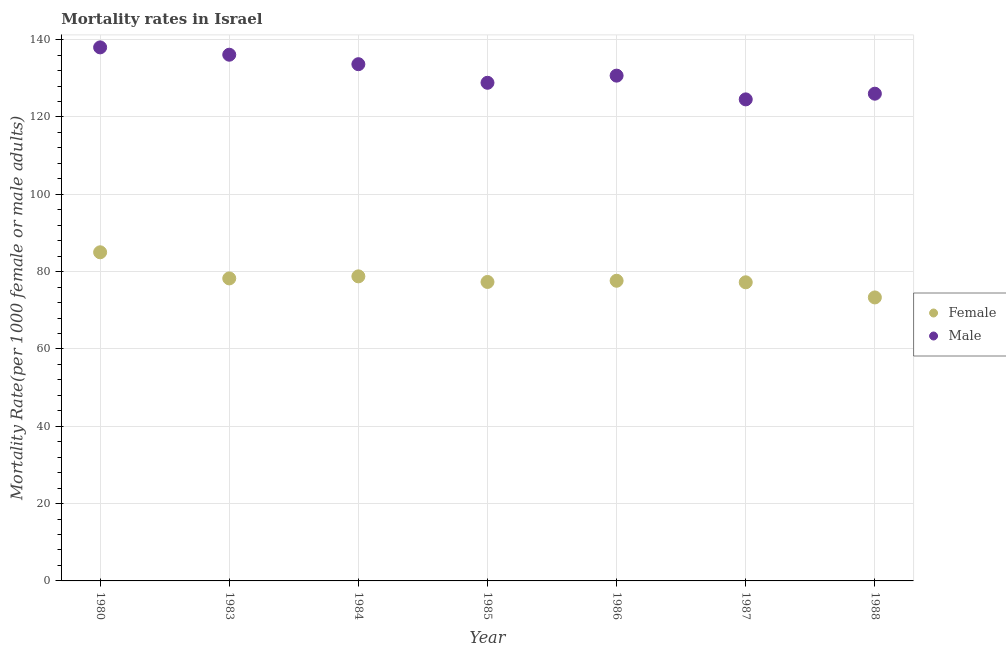How many different coloured dotlines are there?
Offer a terse response. 2. What is the female mortality rate in 1987?
Offer a terse response. 77.24. Across all years, what is the minimum female mortality rate?
Provide a short and direct response. 73.32. What is the total male mortality rate in the graph?
Offer a terse response. 917.86. What is the difference between the male mortality rate in 1987 and that in 1988?
Your answer should be compact. -1.47. What is the difference between the female mortality rate in 1985 and the male mortality rate in 1983?
Your answer should be compact. -58.78. What is the average female mortality rate per year?
Your answer should be very brief. 78.22. In the year 1980, what is the difference between the female mortality rate and male mortality rate?
Your answer should be very brief. -53. What is the ratio of the male mortality rate in 1985 to that in 1986?
Your answer should be compact. 0.99. Is the male mortality rate in 1983 less than that in 1986?
Your response must be concise. No. Is the difference between the female mortality rate in 1980 and 1985 greater than the difference between the male mortality rate in 1980 and 1985?
Your answer should be compact. No. What is the difference between the highest and the second highest female mortality rate?
Provide a short and direct response. 6.22. What is the difference between the highest and the lowest female mortality rate?
Your answer should be very brief. 11.68. Where does the legend appear in the graph?
Provide a succinct answer. Center right. How many legend labels are there?
Give a very brief answer. 2. How are the legend labels stacked?
Offer a very short reply. Vertical. What is the title of the graph?
Make the answer very short. Mortality rates in Israel. What is the label or title of the Y-axis?
Give a very brief answer. Mortality Rate(per 1000 female or male adults). What is the Mortality Rate(per 1000 female or male adults) of Male in 1980?
Make the answer very short. 138. What is the Mortality Rate(per 1000 female or male adults) of Female in 1983?
Provide a short and direct response. 78.24. What is the Mortality Rate(per 1000 female or male adults) in Male in 1983?
Your response must be concise. 136.1. What is the Mortality Rate(per 1000 female or male adults) of Female in 1984?
Your answer should be compact. 78.78. What is the Mortality Rate(per 1000 female or male adults) of Male in 1984?
Make the answer very short. 133.65. What is the Mortality Rate(per 1000 female or male adults) in Female in 1985?
Offer a very short reply. 77.33. What is the Mortality Rate(per 1000 female or male adults) of Male in 1985?
Ensure brevity in your answer.  128.84. What is the Mortality Rate(per 1000 female or male adults) of Female in 1986?
Your response must be concise. 77.64. What is the Mortality Rate(per 1000 female or male adults) in Male in 1986?
Offer a terse response. 130.69. What is the Mortality Rate(per 1000 female or male adults) of Female in 1987?
Offer a terse response. 77.24. What is the Mortality Rate(per 1000 female or male adults) in Male in 1987?
Provide a succinct answer. 124.55. What is the Mortality Rate(per 1000 female or male adults) of Female in 1988?
Offer a very short reply. 73.32. What is the Mortality Rate(per 1000 female or male adults) of Male in 1988?
Provide a short and direct response. 126.02. Across all years, what is the maximum Mortality Rate(per 1000 female or male adults) in Male?
Make the answer very short. 138. Across all years, what is the minimum Mortality Rate(per 1000 female or male adults) of Female?
Provide a short and direct response. 73.32. Across all years, what is the minimum Mortality Rate(per 1000 female or male adults) in Male?
Offer a very short reply. 124.55. What is the total Mortality Rate(per 1000 female or male adults) of Female in the graph?
Ensure brevity in your answer.  547.54. What is the total Mortality Rate(per 1000 female or male adults) of Male in the graph?
Your response must be concise. 917.86. What is the difference between the Mortality Rate(per 1000 female or male adults) of Female in 1980 and that in 1983?
Provide a short and direct response. 6.76. What is the difference between the Mortality Rate(per 1000 female or male adults) of Male in 1980 and that in 1983?
Your answer should be very brief. 1.9. What is the difference between the Mortality Rate(per 1000 female or male adults) in Female in 1980 and that in 1984?
Make the answer very short. 6.22. What is the difference between the Mortality Rate(per 1000 female or male adults) of Male in 1980 and that in 1984?
Your answer should be very brief. 4.35. What is the difference between the Mortality Rate(per 1000 female or male adults) in Female in 1980 and that in 1985?
Offer a very short reply. 7.67. What is the difference between the Mortality Rate(per 1000 female or male adults) of Male in 1980 and that in 1985?
Offer a terse response. 9.16. What is the difference between the Mortality Rate(per 1000 female or male adults) of Female in 1980 and that in 1986?
Offer a very short reply. 7.36. What is the difference between the Mortality Rate(per 1000 female or male adults) of Male in 1980 and that in 1986?
Your answer should be compact. 7.31. What is the difference between the Mortality Rate(per 1000 female or male adults) of Female in 1980 and that in 1987?
Offer a terse response. 7.76. What is the difference between the Mortality Rate(per 1000 female or male adults) in Male in 1980 and that in 1987?
Provide a succinct answer. 13.45. What is the difference between the Mortality Rate(per 1000 female or male adults) in Female in 1980 and that in 1988?
Your answer should be compact. 11.68. What is the difference between the Mortality Rate(per 1000 female or male adults) in Male in 1980 and that in 1988?
Offer a very short reply. 11.98. What is the difference between the Mortality Rate(per 1000 female or male adults) in Female in 1983 and that in 1984?
Keep it short and to the point. -0.53. What is the difference between the Mortality Rate(per 1000 female or male adults) of Male in 1983 and that in 1984?
Offer a very short reply. 2.45. What is the difference between the Mortality Rate(per 1000 female or male adults) of Female in 1983 and that in 1985?
Make the answer very short. 0.92. What is the difference between the Mortality Rate(per 1000 female or male adults) of Male in 1983 and that in 1985?
Make the answer very short. 7.26. What is the difference between the Mortality Rate(per 1000 female or male adults) in Female in 1983 and that in 1986?
Offer a terse response. 0.61. What is the difference between the Mortality Rate(per 1000 female or male adults) of Male in 1983 and that in 1986?
Make the answer very short. 5.41. What is the difference between the Mortality Rate(per 1000 female or male adults) of Male in 1983 and that in 1987?
Provide a short and direct response. 11.55. What is the difference between the Mortality Rate(per 1000 female or male adults) of Female in 1983 and that in 1988?
Give a very brief answer. 4.92. What is the difference between the Mortality Rate(per 1000 female or male adults) in Male in 1983 and that in 1988?
Keep it short and to the point. 10.08. What is the difference between the Mortality Rate(per 1000 female or male adults) of Female in 1984 and that in 1985?
Give a very brief answer. 1.45. What is the difference between the Mortality Rate(per 1000 female or male adults) in Male in 1984 and that in 1985?
Keep it short and to the point. 4.81. What is the difference between the Mortality Rate(per 1000 female or male adults) in Female in 1984 and that in 1986?
Offer a terse response. 1.14. What is the difference between the Mortality Rate(per 1000 female or male adults) of Male in 1984 and that in 1986?
Give a very brief answer. 2.96. What is the difference between the Mortality Rate(per 1000 female or male adults) in Female in 1984 and that in 1987?
Make the answer very short. 1.54. What is the difference between the Mortality Rate(per 1000 female or male adults) in Male in 1984 and that in 1987?
Provide a short and direct response. 9.1. What is the difference between the Mortality Rate(per 1000 female or male adults) of Female in 1984 and that in 1988?
Your answer should be very brief. 5.45. What is the difference between the Mortality Rate(per 1000 female or male adults) of Male in 1984 and that in 1988?
Give a very brief answer. 7.63. What is the difference between the Mortality Rate(per 1000 female or male adults) in Female in 1985 and that in 1986?
Make the answer very short. -0.31. What is the difference between the Mortality Rate(per 1000 female or male adults) in Male in 1985 and that in 1986?
Your answer should be compact. -1.85. What is the difference between the Mortality Rate(per 1000 female or male adults) in Female in 1985 and that in 1987?
Your answer should be very brief. 0.09. What is the difference between the Mortality Rate(per 1000 female or male adults) of Male in 1985 and that in 1987?
Make the answer very short. 4.29. What is the difference between the Mortality Rate(per 1000 female or male adults) in Female in 1985 and that in 1988?
Make the answer very short. 4. What is the difference between the Mortality Rate(per 1000 female or male adults) of Male in 1985 and that in 1988?
Offer a terse response. 2.82. What is the difference between the Mortality Rate(per 1000 female or male adults) of Female in 1986 and that in 1987?
Offer a terse response. 0.4. What is the difference between the Mortality Rate(per 1000 female or male adults) in Male in 1986 and that in 1987?
Your response must be concise. 6.14. What is the difference between the Mortality Rate(per 1000 female or male adults) in Female in 1986 and that in 1988?
Ensure brevity in your answer.  4.31. What is the difference between the Mortality Rate(per 1000 female or male adults) in Male in 1986 and that in 1988?
Offer a terse response. 4.67. What is the difference between the Mortality Rate(per 1000 female or male adults) in Female in 1987 and that in 1988?
Ensure brevity in your answer.  3.92. What is the difference between the Mortality Rate(per 1000 female or male adults) in Male in 1987 and that in 1988?
Offer a very short reply. -1.47. What is the difference between the Mortality Rate(per 1000 female or male adults) of Female in 1980 and the Mortality Rate(per 1000 female or male adults) of Male in 1983?
Make the answer very short. -51.1. What is the difference between the Mortality Rate(per 1000 female or male adults) in Female in 1980 and the Mortality Rate(per 1000 female or male adults) in Male in 1984?
Offer a terse response. -48.65. What is the difference between the Mortality Rate(per 1000 female or male adults) in Female in 1980 and the Mortality Rate(per 1000 female or male adults) in Male in 1985?
Give a very brief answer. -43.84. What is the difference between the Mortality Rate(per 1000 female or male adults) of Female in 1980 and the Mortality Rate(per 1000 female or male adults) of Male in 1986?
Provide a short and direct response. -45.69. What is the difference between the Mortality Rate(per 1000 female or male adults) in Female in 1980 and the Mortality Rate(per 1000 female or male adults) in Male in 1987?
Make the answer very short. -39.55. What is the difference between the Mortality Rate(per 1000 female or male adults) in Female in 1980 and the Mortality Rate(per 1000 female or male adults) in Male in 1988?
Your answer should be very brief. -41.02. What is the difference between the Mortality Rate(per 1000 female or male adults) in Female in 1983 and the Mortality Rate(per 1000 female or male adults) in Male in 1984?
Keep it short and to the point. -55.41. What is the difference between the Mortality Rate(per 1000 female or male adults) of Female in 1983 and the Mortality Rate(per 1000 female or male adults) of Male in 1985?
Your answer should be compact. -50.6. What is the difference between the Mortality Rate(per 1000 female or male adults) of Female in 1983 and the Mortality Rate(per 1000 female or male adults) of Male in 1986?
Give a very brief answer. -52.45. What is the difference between the Mortality Rate(per 1000 female or male adults) in Female in 1983 and the Mortality Rate(per 1000 female or male adults) in Male in 1987?
Make the answer very short. -46.31. What is the difference between the Mortality Rate(per 1000 female or male adults) in Female in 1983 and the Mortality Rate(per 1000 female or male adults) in Male in 1988?
Offer a terse response. -47.78. What is the difference between the Mortality Rate(per 1000 female or male adults) in Female in 1984 and the Mortality Rate(per 1000 female or male adults) in Male in 1985?
Provide a succinct answer. -50.07. What is the difference between the Mortality Rate(per 1000 female or male adults) in Female in 1984 and the Mortality Rate(per 1000 female or male adults) in Male in 1986?
Ensure brevity in your answer.  -51.91. What is the difference between the Mortality Rate(per 1000 female or male adults) of Female in 1984 and the Mortality Rate(per 1000 female or male adults) of Male in 1987?
Offer a terse response. -45.77. What is the difference between the Mortality Rate(per 1000 female or male adults) of Female in 1984 and the Mortality Rate(per 1000 female or male adults) of Male in 1988?
Your answer should be compact. -47.25. What is the difference between the Mortality Rate(per 1000 female or male adults) of Female in 1985 and the Mortality Rate(per 1000 female or male adults) of Male in 1986?
Offer a very short reply. -53.37. What is the difference between the Mortality Rate(per 1000 female or male adults) of Female in 1985 and the Mortality Rate(per 1000 female or male adults) of Male in 1987?
Your answer should be very brief. -47.23. What is the difference between the Mortality Rate(per 1000 female or male adults) of Female in 1985 and the Mortality Rate(per 1000 female or male adults) of Male in 1988?
Offer a very short reply. -48.7. What is the difference between the Mortality Rate(per 1000 female or male adults) of Female in 1986 and the Mortality Rate(per 1000 female or male adults) of Male in 1987?
Keep it short and to the point. -46.91. What is the difference between the Mortality Rate(per 1000 female or male adults) in Female in 1986 and the Mortality Rate(per 1000 female or male adults) in Male in 1988?
Offer a terse response. -48.39. What is the difference between the Mortality Rate(per 1000 female or male adults) of Female in 1987 and the Mortality Rate(per 1000 female or male adults) of Male in 1988?
Offer a terse response. -48.78. What is the average Mortality Rate(per 1000 female or male adults) in Female per year?
Your answer should be very brief. 78.22. What is the average Mortality Rate(per 1000 female or male adults) of Male per year?
Offer a very short reply. 131.12. In the year 1980, what is the difference between the Mortality Rate(per 1000 female or male adults) in Female and Mortality Rate(per 1000 female or male adults) in Male?
Provide a short and direct response. -53. In the year 1983, what is the difference between the Mortality Rate(per 1000 female or male adults) of Female and Mortality Rate(per 1000 female or male adults) of Male?
Offer a very short reply. -57.86. In the year 1984, what is the difference between the Mortality Rate(per 1000 female or male adults) in Female and Mortality Rate(per 1000 female or male adults) in Male?
Your answer should be compact. -54.88. In the year 1985, what is the difference between the Mortality Rate(per 1000 female or male adults) in Female and Mortality Rate(per 1000 female or male adults) in Male?
Provide a short and direct response. -51.52. In the year 1986, what is the difference between the Mortality Rate(per 1000 female or male adults) of Female and Mortality Rate(per 1000 female or male adults) of Male?
Offer a very short reply. -53.05. In the year 1987, what is the difference between the Mortality Rate(per 1000 female or male adults) of Female and Mortality Rate(per 1000 female or male adults) of Male?
Make the answer very short. -47.31. In the year 1988, what is the difference between the Mortality Rate(per 1000 female or male adults) of Female and Mortality Rate(per 1000 female or male adults) of Male?
Make the answer very short. -52.7. What is the ratio of the Mortality Rate(per 1000 female or male adults) in Female in 1980 to that in 1983?
Give a very brief answer. 1.09. What is the ratio of the Mortality Rate(per 1000 female or male adults) in Male in 1980 to that in 1983?
Offer a very short reply. 1.01. What is the ratio of the Mortality Rate(per 1000 female or male adults) of Female in 1980 to that in 1984?
Ensure brevity in your answer.  1.08. What is the ratio of the Mortality Rate(per 1000 female or male adults) of Male in 1980 to that in 1984?
Your answer should be very brief. 1.03. What is the ratio of the Mortality Rate(per 1000 female or male adults) in Female in 1980 to that in 1985?
Your response must be concise. 1.1. What is the ratio of the Mortality Rate(per 1000 female or male adults) of Male in 1980 to that in 1985?
Ensure brevity in your answer.  1.07. What is the ratio of the Mortality Rate(per 1000 female or male adults) in Female in 1980 to that in 1986?
Give a very brief answer. 1.09. What is the ratio of the Mortality Rate(per 1000 female or male adults) of Male in 1980 to that in 1986?
Provide a succinct answer. 1.06. What is the ratio of the Mortality Rate(per 1000 female or male adults) of Female in 1980 to that in 1987?
Provide a succinct answer. 1.1. What is the ratio of the Mortality Rate(per 1000 female or male adults) in Male in 1980 to that in 1987?
Your answer should be very brief. 1.11. What is the ratio of the Mortality Rate(per 1000 female or male adults) in Female in 1980 to that in 1988?
Offer a terse response. 1.16. What is the ratio of the Mortality Rate(per 1000 female or male adults) of Male in 1980 to that in 1988?
Offer a terse response. 1.09. What is the ratio of the Mortality Rate(per 1000 female or male adults) of Female in 1983 to that in 1984?
Ensure brevity in your answer.  0.99. What is the ratio of the Mortality Rate(per 1000 female or male adults) of Male in 1983 to that in 1984?
Provide a succinct answer. 1.02. What is the ratio of the Mortality Rate(per 1000 female or male adults) of Female in 1983 to that in 1985?
Your answer should be very brief. 1.01. What is the ratio of the Mortality Rate(per 1000 female or male adults) in Male in 1983 to that in 1985?
Your answer should be compact. 1.06. What is the ratio of the Mortality Rate(per 1000 female or male adults) in Male in 1983 to that in 1986?
Your answer should be very brief. 1.04. What is the ratio of the Mortality Rate(per 1000 female or male adults) of Female in 1983 to that in 1987?
Ensure brevity in your answer.  1.01. What is the ratio of the Mortality Rate(per 1000 female or male adults) of Male in 1983 to that in 1987?
Offer a terse response. 1.09. What is the ratio of the Mortality Rate(per 1000 female or male adults) of Female in 1983 to that in 1988?
Provide a short and direct response. 1.07. What is the ratio of the Mortality Rate(per 1000 female or male adults) of Male in 1983 to that in 1988?
Give a very brief answer. 1.08. What is the ratio of the Mortality Rate(per 1000 female or male adults) in Female in 1984 to that in 1985?
Make the answer very short. 1.02. What is the ratio of the Mortality Rate(per 1000 female or male adults) in Male in 1984 to that in 1985?
Give a very brief answer. 1.04. What is the ratio of the Mortality Rate(per 1000 female or male adults) of Female in 1984 to that in 1986?
Ensure brevity in your answer.  1.01. What is the ratio of the Mortality Rate(per 1000 female or male adults) of Male in 1984 to that in 1986?
Your answer should be compact. 1.02. What is the ratio of the Mortality Rate(per 1000 female or male adults) in Female in 1984 to that in 1987?
Make the answer very short. 1.02. What is the ratio of the Mortality Rate(per 1000 female or male adults) in Male in 1984 to that in 1987?
Your answer should be very brief. 1.07. What is the ratio of the Mortality Rate(per 1000 female or male adults) in Female in 1984 to that in 1988?
Make the answer very short. 1.07. What is the ratio of the Mortality Rate(per 1000 female or male adults) in Male in 1984 to that in 1988?
Your answer should be very brief. 1.06. What is the ratio of the Mortality Rate(per 1000 female or male adults) in Male in 1985 to that in 1986?
Make the answer very short. 0.99. What is the ratio of the Mortality Rate(per 1000 female or male adults) in Male in 1985 to that in 1987?
Your answer should be very brief. 1.03. What is the ratio of the Mortality Rate(per 1000 female or male adults) of Female in 1985 to that in 1988?
Provide a succinct answer. 1.05. What is the ratio of the Mortality Rate(per 1000 female or male adults) of Male in 1985 to that in 1988?
Offer a very short reply. 1.02. What is the ratio of the Mortality Rate(per 1000 female or male adults) of Female in 1986 to that in 1987?
Ensure brevity in your answer.  1.01. What is the ratio of the Mortality Rate(per 1000 female or male adults) in Male in 1986 to that in 1987?
Provide a succinct answer. 1.05. What is the ratio of the Mortality Rate(per 1000 female or male adults) in Female in 1986 to that in 1988?
Give a very brief answer. 1.06. What is the ratio of the Mortality Rate(per 1000 female or male adults) in Male in 1986 to that in 1988?
Your answer should be very brief. 1.04. What is the ratio of the Mortality Rate(per 1000 female or male adults) in Female in 1987 to that in 1988?
Make the answer very short. 1.05. What is the ratio of the Mortality Rate(per 1000 female or male adults) in Male in 1987 to that in 1988?
Your answer should be very brief. 0.99. What is the difference between the highest and the second highest Mortality Rate(per 1000 female or male adults) of Female?
Your answer should be very brief. 6.22. What is the difference between the highest and the second highest Mortality Rate(per 1000 female or male adults) of Male?
Offer a very short reply. 1.9. What is the difference between the highest and the lowest Mortality Rate(per 1000 female or male adults) in Female?
Give a very brief answer. 11.68. What is the difference between the highest and the lowest Mortality Rate(per 1000 female or male adults) of Male?
Your answer should be compact. 13.45. 